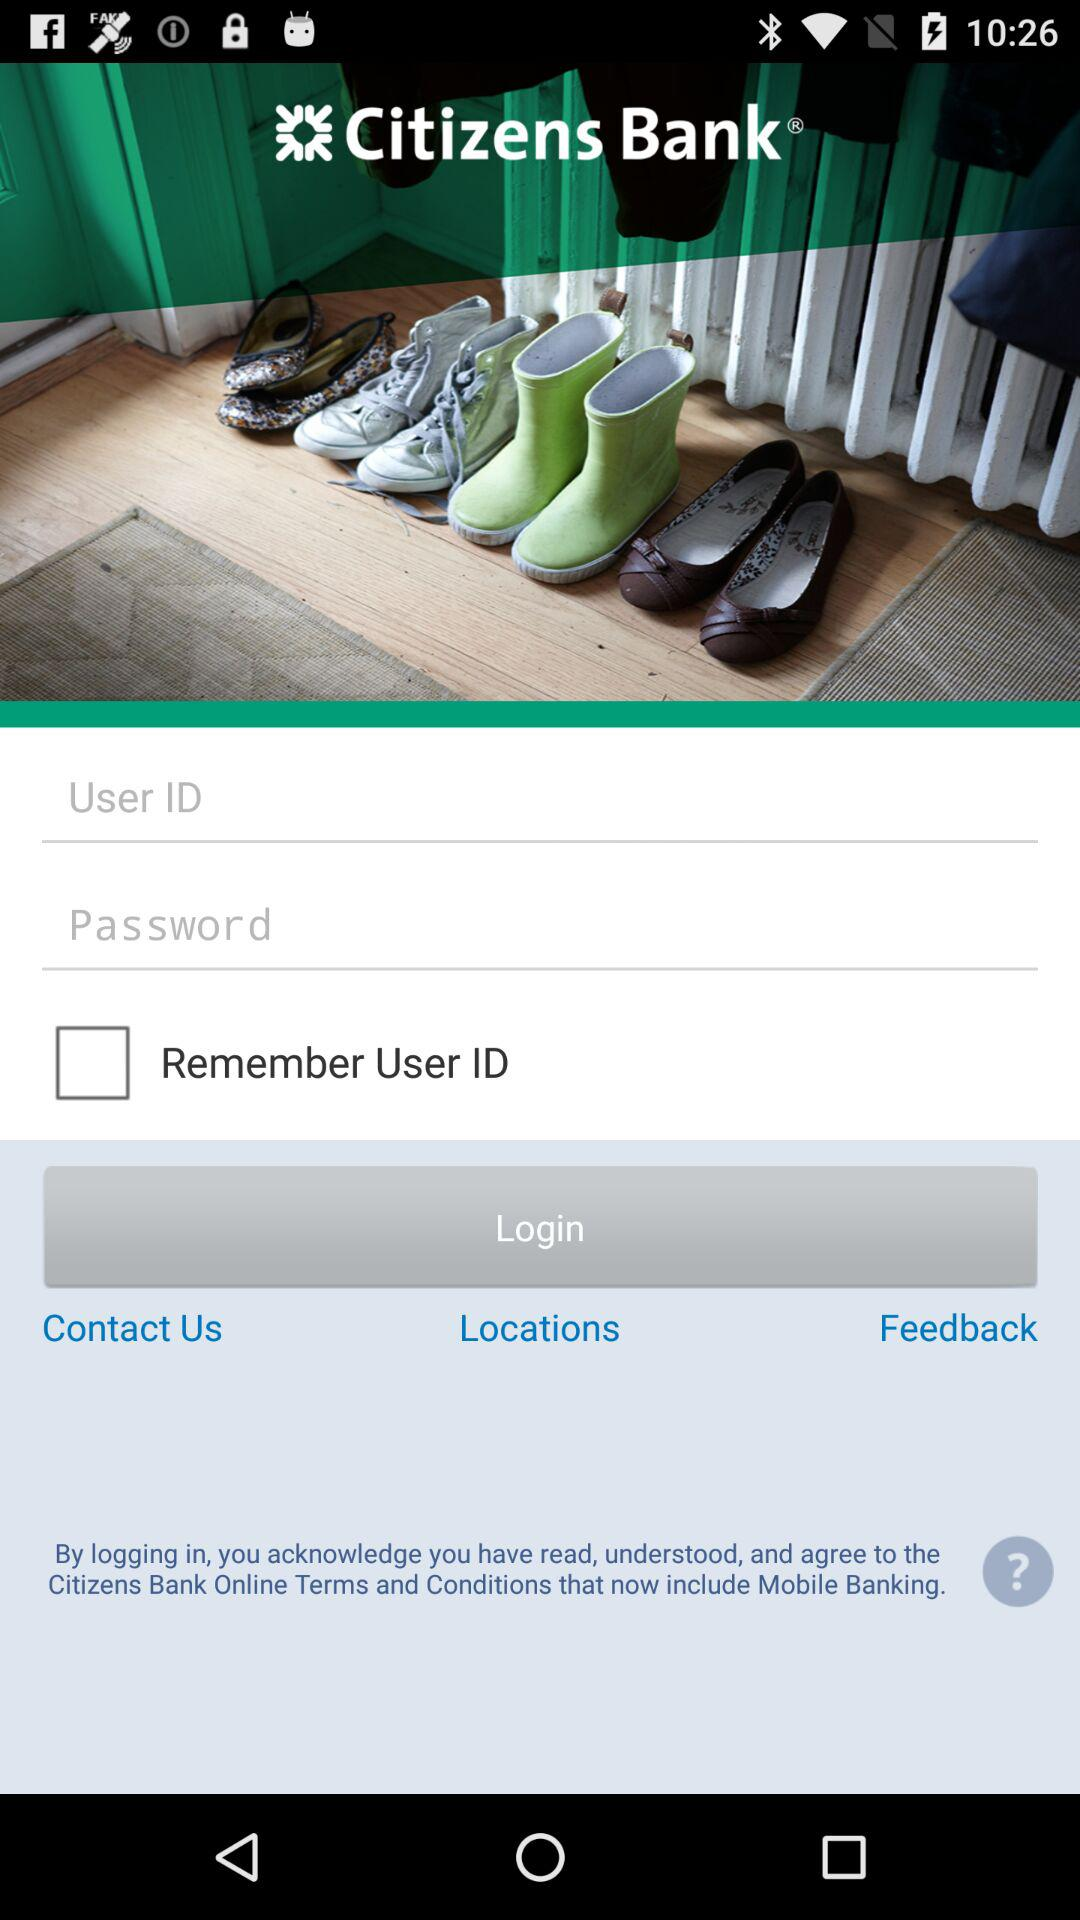What is the status of "Remember User ID"? The status is "off". 